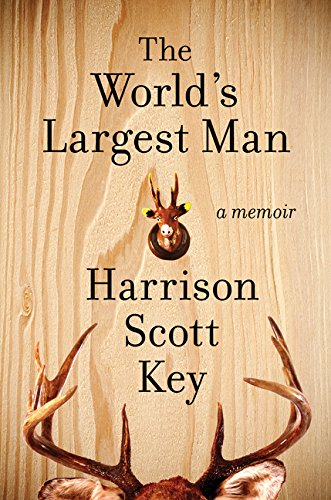Is this book related to Christian Books & Bibles? No, this book does not fall under the category of Christian Books & Bibles. It is primarily categorized as a humorous memoir. 